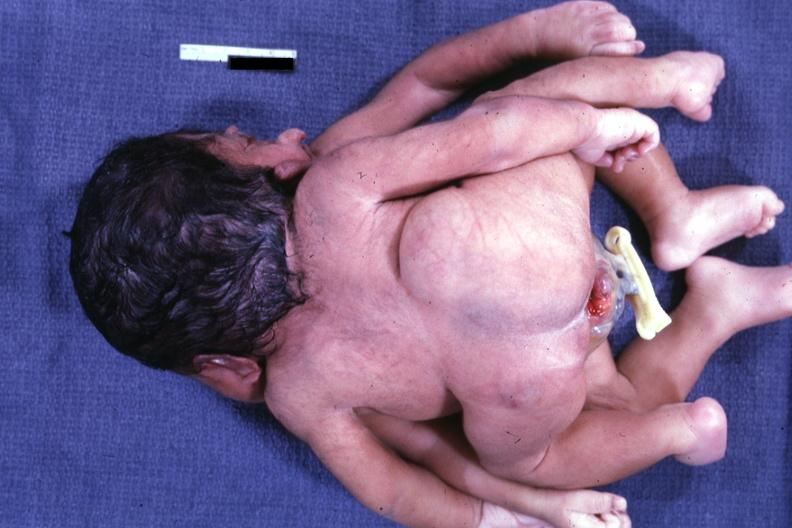what joined at head and chest?
Answer the question using a single word or phrase. View of twin 